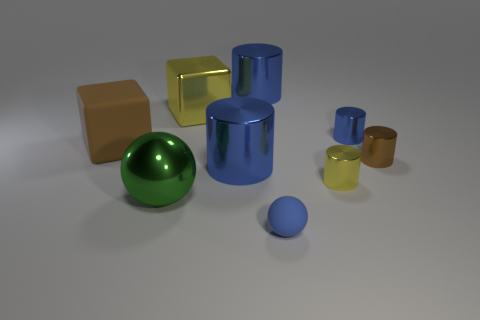Subtract all blue cylinders. How many were subtracted if there are1blue cylinders left? 2 Subtract all brown blocks. How many blue cylinders are left? 3 Subtract all yellow cylinders. How many cylinders are left? 4 Subtract all brown cylinders. How many cylinders are left? 4 Subtract 1 cylinders. How many cylinders are left? 4 Subtract all cyan cylinders. Subtract all blue cubes. How many cylinders are left? 5 Add 1 metal cubes. How many objects exist? 10 Subtract all spheres. How many objects are left? 7 Subtract 0 purple cubes. How many objects are left? 9 Subtract all large brown matte cubes. Subtract all large yellow metal blocks. How many objects are left? 7 